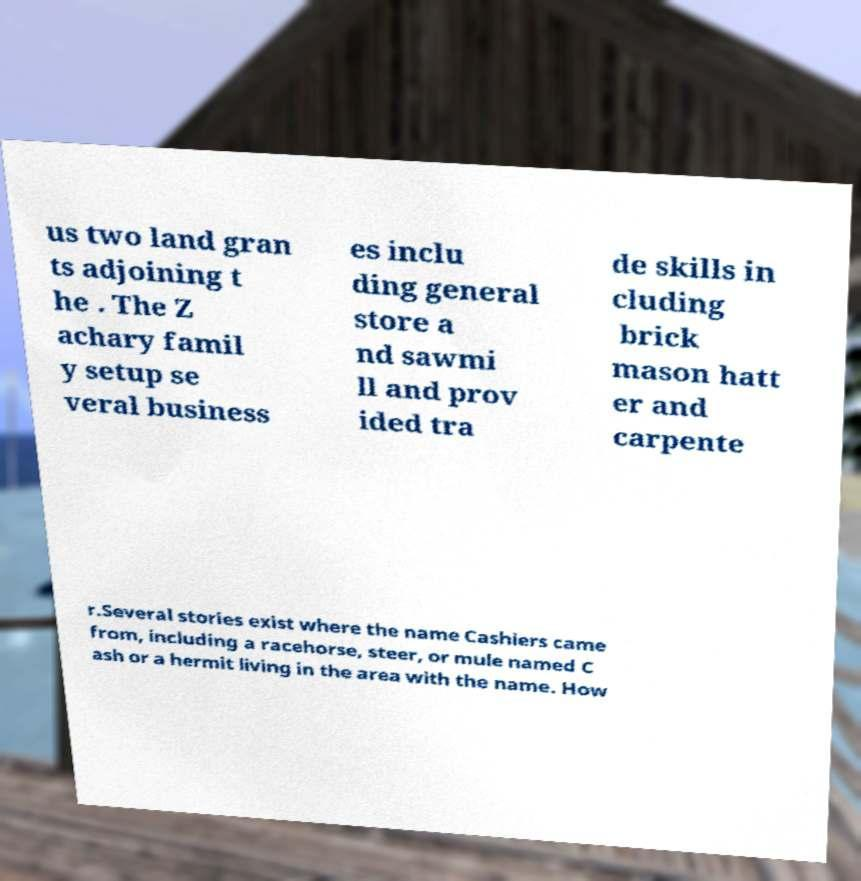Please identify and transcribe the text found in this image. us two land gran ts adjoining t he . The Z achary famil y setup se veral business es inclu ding general store a nd sawmi ll and prov ided tra de skills in cluding brick mason hatt er and carpente r.Several stories exist where the name Cashiers came from, including a racehorse, steer, or mule named C ash or a hermit living in the area with the name. How 